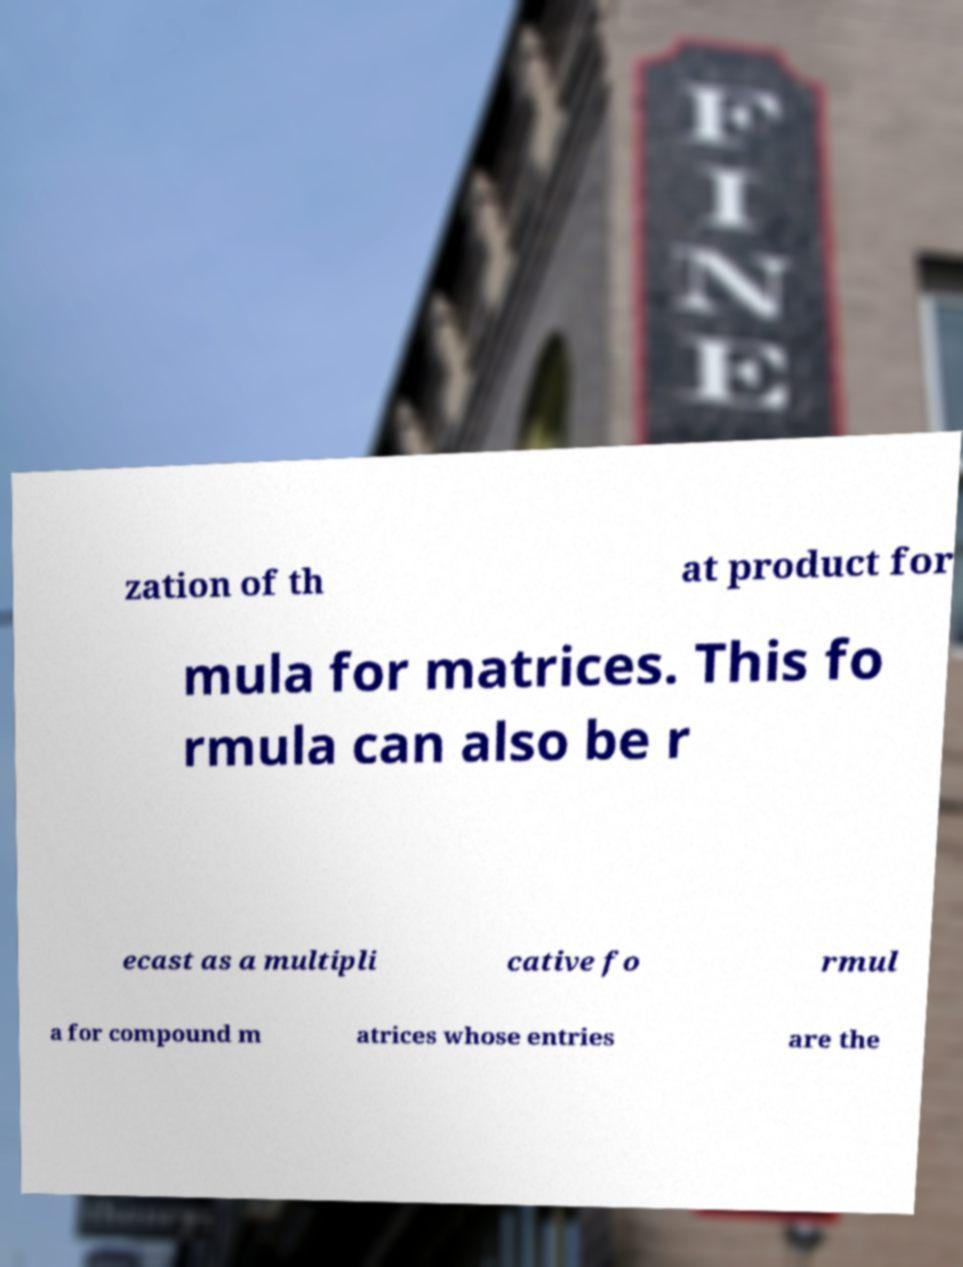Please read and relay the text visible in this image. What does it say? zation of th at product for mula for matrices. This fo rmula can also be r ecast as a multipli cative fo rmul a for compound m atrices whose entries are the 